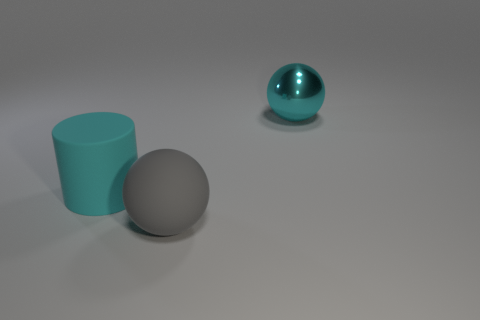Is there anything else that has the same material as the cyan sphere?
Your answer should be very brief. No. There is another thing that is the same shape as the large cyan metallic thing; what is it made of?
Keep it short and to the point. Rubber. Do the cyan rubber thing and the big cyan shiny object have the same shape?
Make the answer very short. No. There is a large shiny object; does it have the same shape as the cyan object that is to the left of the cyan metallic ball?
Offer a very short reply. No. The ball to the left of the large sphere to the right of the big thing that is in front of the large cyan matte thing is what color?
Your response must be concise. Gray. There is a large object that is behind the rubber cylinder; is its shape the same as the gray object?
Your response must be concise. Yes. What is the material of the big gray thing?
Give a very brief answer. Rubber. The rubber object that is behind the ball that is to the left of the big ball that is behind the gray ball is what shape?
Make the answer very short. Cylinder. What number of other things are there of the same shape as the large gray rubber object?
Your answer should be compact. 1. There is a large cylinder; is it the same color as the object that is right of the big gray matte object?
Ensure brevity in your answer.  Yes. 